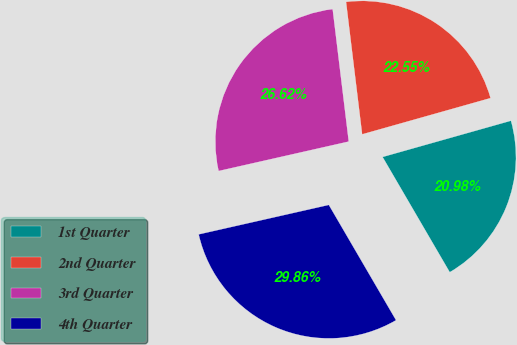<chart> <loc_0><loc_0><loc_500><loc_500><pie_chart><fcel>1st Quarter<fcel>2nd Quarter<fcel>3rd Quarter<fcel>4th Quarter<nl><fcel>20.98%<fcel>22.55%<fcel>26.62%<fcel>29.86%<nl></chart> 